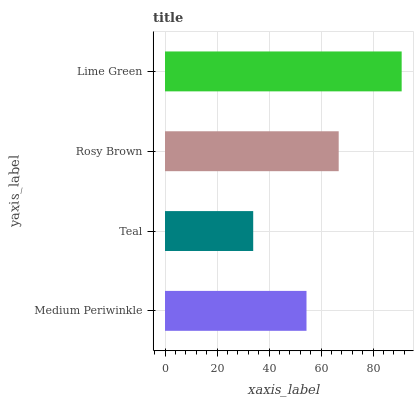Is Teal the minimum?
Answer yes or no. Yes. Is Lime Green the maximum?
Answer yes or no. Yes. Is Rosy Brown the minimum?
Answer yes or no. No. Is Rosy Brown the maximum?
Answer yes or no. No. Is Rosy Brown greater than Teal?
Answer yes or no. Yes. Is Teal less than Rosy Brown?
Answer yes or no. Yes. Is Teal greater than Rosy Brown?
Answer yes or no. No. Is Rosy Brown less than Teal?
Answer yes or no. No. Is Rosy Brown the high median?
Answer yes or no. Yes. Is Medium Periwinkle the low median?
Answer yes or no. Yes. Is Teal the high median?
Answer yes or no. No. Is Lime Green the low median?
Answer yes or no. No. 